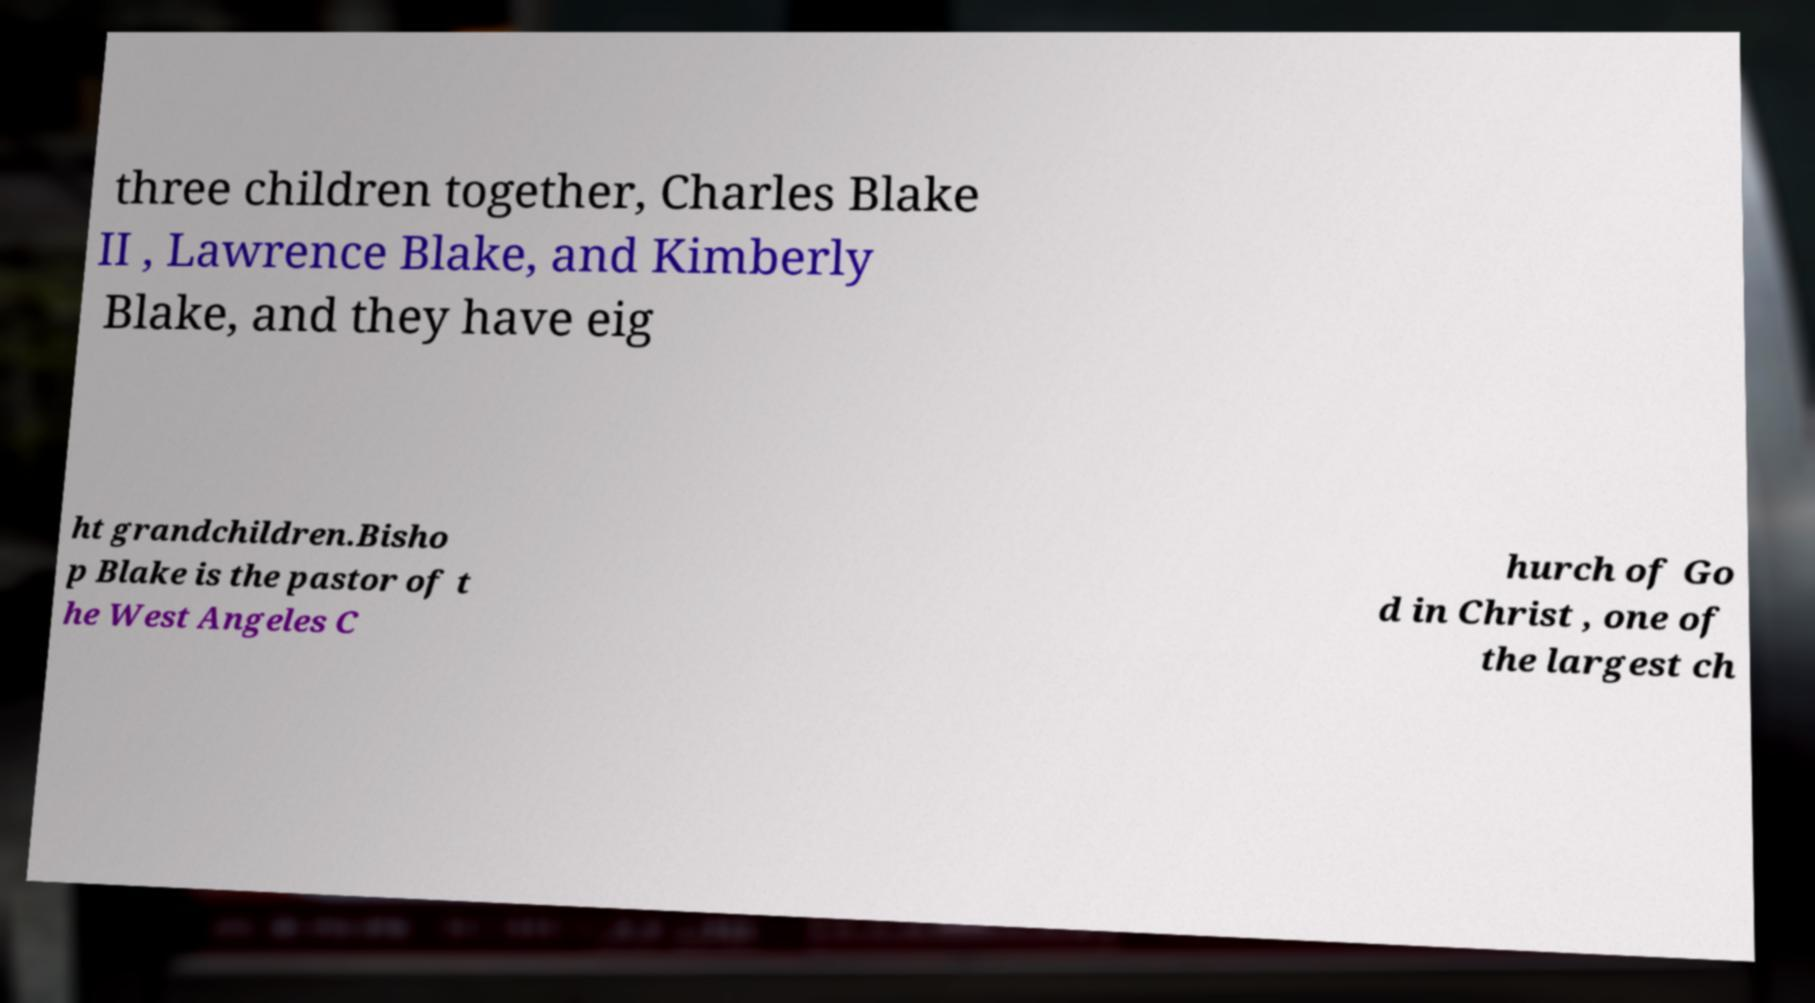Please identify and transcribe the text found in this image. three children together, Charles Blake II , Lawrence Blake, and Kimberly Blake, and they have eig ht grandchildren.Bisho p Blake is the pastor of t he West Angeles C hurch of Go d in Christ , one of the largest ch 